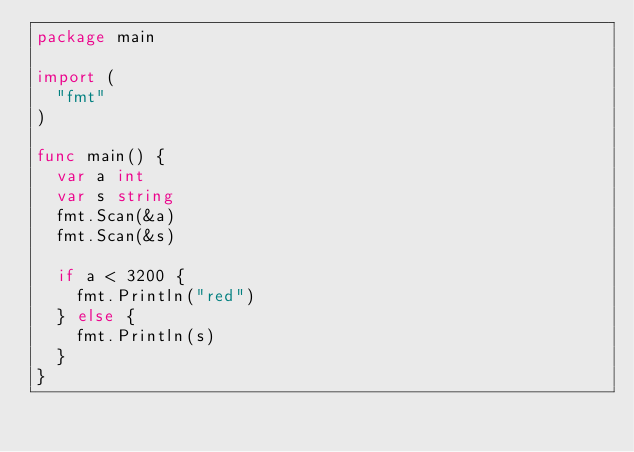<code> <loc_0><loc_0><loc_500><loc_500><_Go_>package main

import (
	"fmt"
)

func main() {
	var a int
	var s string
	fmt.Scan(&a)
	fmt.Scan(&s)

	if a < 3200 {
		fmt.Println("red")
	} else {
		fmt.Println(s)
	}
}
</code> 